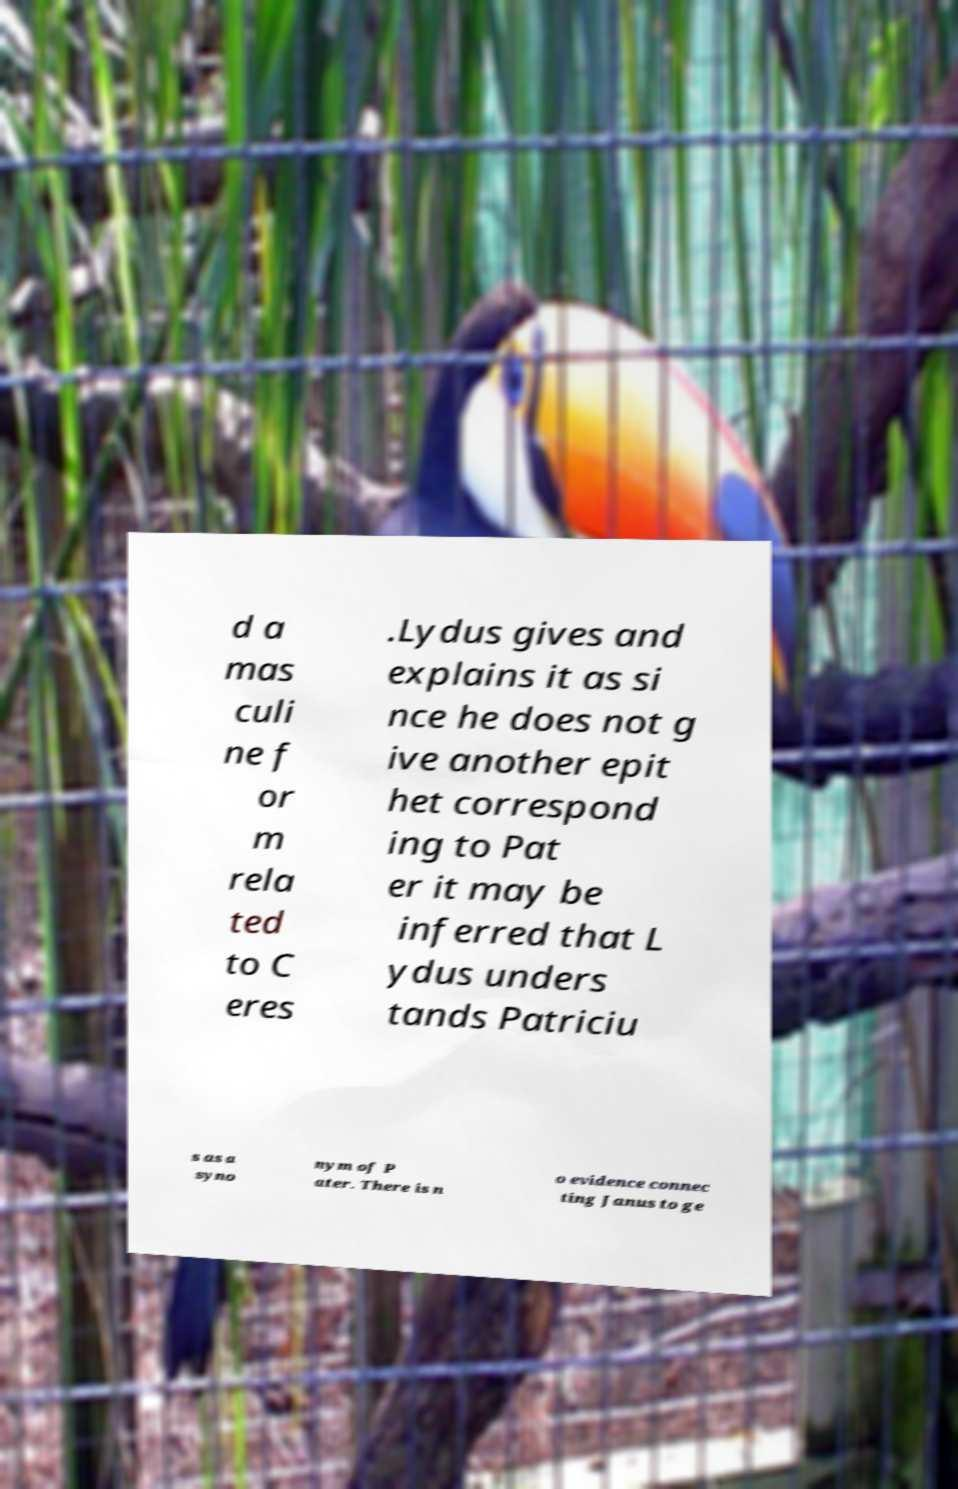Could you extract and type out the text from this image? d a mas culi ne f or m rela ted to C eres .Lydus gives and explains it as si nce he does not g ive another epit het correspond ing to Pat er it may be inferred that L ydus unders tands Patriciu s as a syno nym of P ater. There is n o evidence connec ting Janus to ge 